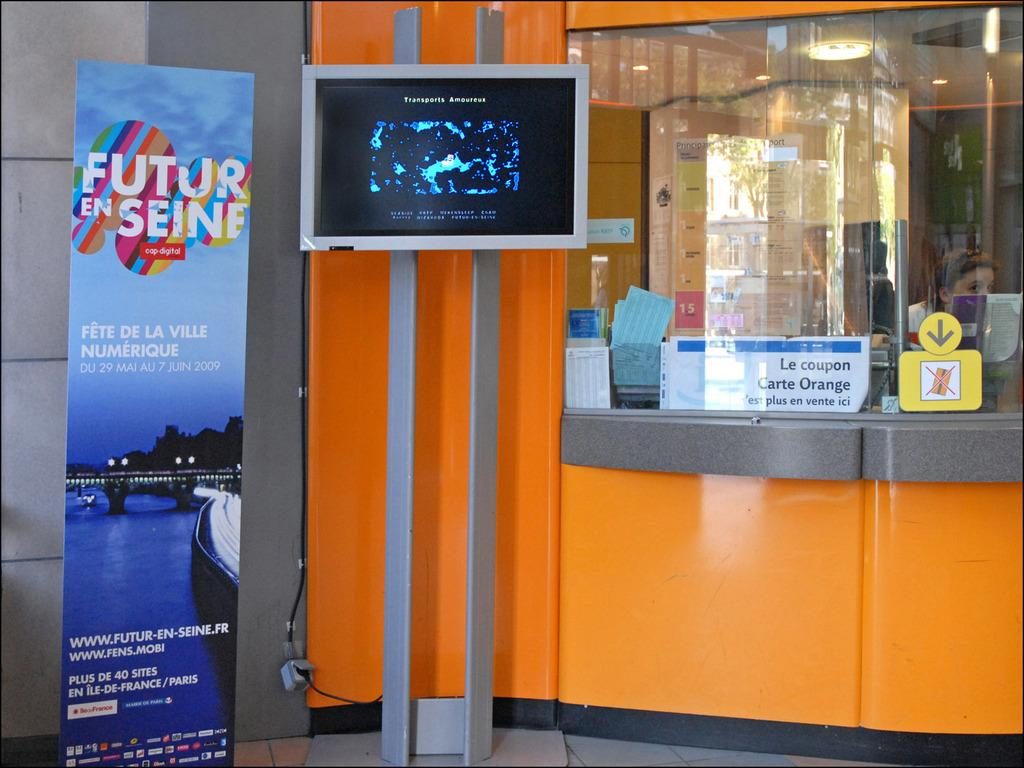<image>
Write a terse but informative summary of the picture. A television next to a standee that says Futur En Seine. 